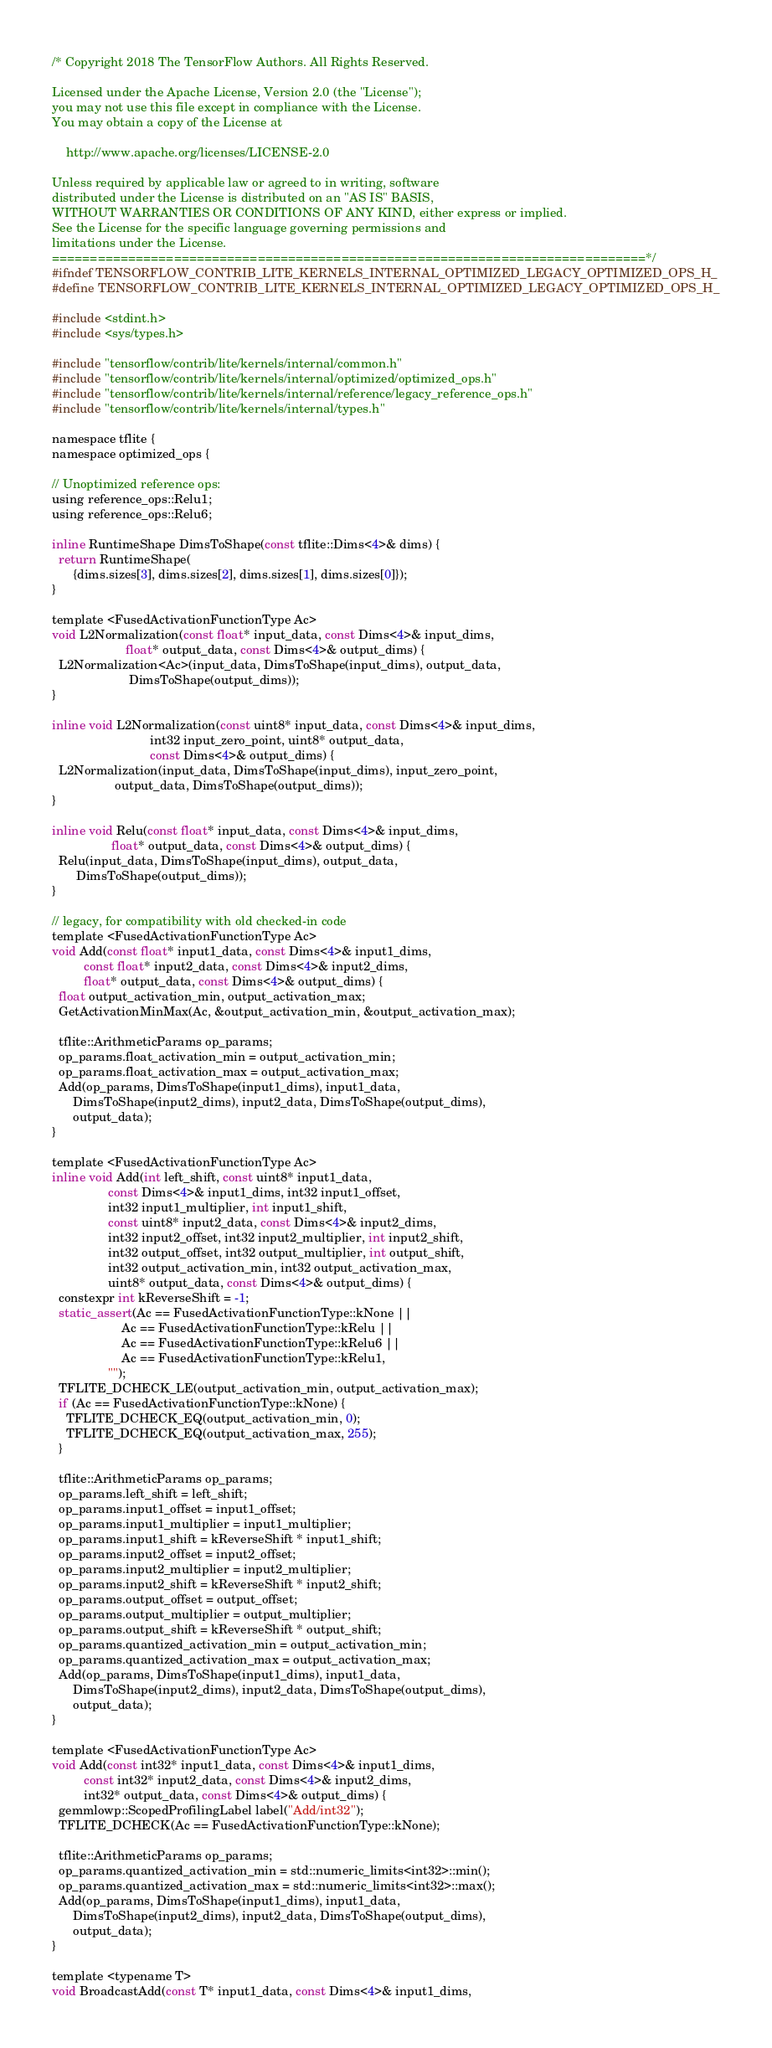<code> <loc_0><loc_0><loc_500><loc_500><_C_>/* Copyright 2018 The TensorFlow Authors. All Rights Reserved.

Licensed under the Apache License, Version 2.0 (the "License");
you may not use this file except in compliance with the License.
You may obtain a copy of the License at

    http://www.apache.org/licenses/LICENSE-2.0

Unless required by applicable law or agreed to in writing, software
distributed under the License is distributed on an "AS IS" BASIS,
WITHOUT WARRANTIES OR CONDITIONS OF ANY KIND, either express or implied.
See the License for the specific language governing permissions and
limitations under the License.
==============================================================================*/
#ifndef TENSORFLOW_CONTRIB_LITE_KERNELS_INTERNAL_OPTIMIZED_LEGACY_OPTIMIZED_OPS_H_
#define TENSORFLOW_CONTRIB_LITE_KERNELS_INTERNAL_OPTIMIZED_LEGACY_OPTIMIZED_OPS_H_

#include <stdint.h>
#include <sys/types.h>

#include "tensorflow/contrib/lite/kernels/internal/common.h"
#include "tensorflow/contrib/lite/kernels/internal/optimized/optimized_ops.h"
#include "tensorflow/contrib/lite/kernels/internal/reference/legacy_reference_ops.h"
#include "tensorflow/contrib/lite/kernels/internal/types.h"

namespace tflite {
namespace optimized_ops {

// Unoptimized reference ops:
using reference_ops::Relu1;
using reference_ops::Relu6;

inline RuntimeShape DimsToShape(const tflite::Dims<4>& dims) {
  return RuntimeShape(
      {dims.sizes[3], dims.sizes[2], dims.sizes[1], dims.sizes[0]});
}

template <FusedActivationFunctionType Ac>
void L2Normalization(const float* input_data, const Dims<4>& input_dims,
                     float* output_data, const Dims<4>& output_dims) {
  L2Normalization<Ac>(input_data, DimsToShape(input_dims), output_data,
                      DimsToShape(output_dims));
}

inline void L2Normalization(const uint8* input_data, const Dims<4>& input_dims,
                            int32 input_zero_point, uint8* output_data,
                            const Dims<4>& output_dims) {
  L2Normalization(input_data, DimsToShape(input_dims), input_zero_point,
                  output_data, DimsToShape(output_dims));
}

inline void Relu(const float* input_data, const Dims<4>& input_dims,
                 float* output_data, const Dims<4>& output_dims) {
  Relu(input_data, DimsToShape(input_dims), output_data,
       DimsToShape(output_dims));
}

// legacy, for compatibility with old checked-in code
template <FusedActivationFunctionType Ac>
void Add(const float* input1_data, const Dims<4>& input1_dims,
         const float* input2_data, const Dims<4>& input2_dims,
         float* output_data, const Dims<4>& output_dims) {
  float output_activation_min, output_activation_max;
  GetActivationMinMax(Ac, &output_activation_min, &output_activation_max);

  tflite::ArithmeticParams op_params;
  op_params.float_activation_min = output_activation_min;
  op_params.float_activation_max = output_activation_max;
  Add(op_params, DimsToShape(input1_dims), input1_data,
      DimsToShape(input2_dims), input2_data, DimsToShape(output_dims),
      output_data);
}

template <FusedActivationFunctionType Ac>
inline void Add(int left_shift, const uint8* input1_data,
                const Dims<4>& input1_dims, int32 input1_offset,
                int32 input1_multiplier, int input1_shift,
                const uint8* input2_data, const Dims<4>& input2_dims,
                int32 input2_offset, int32 input2_multiplier, int input2_shift,
                int32 output_offset, int32 output_multiplier, int output_shift,
                int32 output_activation_min, int32 output_activation_max,
                uint8* output_data, const Dims<4>& output_dims) {
  constexpr int kReverseShift = -1;
  static_assert(Ac == FusedActivationFunctionType::kNone ||
                    Ac == FusedActivationFunctionType::kRelu ||
                    Ac == FusedActivationFunctionType::kRelu6 ||
                    Ac == FusedActivationFunctionType::kRelu1,
                "");
  TFLITE_DCHECK_LE(output_activation_min, output_activation_max);
  if (Ac == FusedActivationFunctionType::kNone) {
    TFLITE_DCHECK_EQ(output_activation_min, 0);
    TFLITE_DCHECK_EQ(output_activation_max, 255);
  }

  tflite::ArithmeticParams op_params;
  op_params.left_shift = left_shift;
  op_params.input1_offset = input1_offset;
  op_params.input1_multiplier = input1_multiplier;
  op_params.input1_shift = kReverseShift * input1_shift;
  op_params.input2_offset = input2_offset;
  op_params.input2_multiplier = input2_multiplier;
  op_params.input2_shift = kReverseShift * input2_shift;
  op_params.output_offset = output_offset;
  op_params.output_multiplier = output_multiplier;
  op_params.output_shift = kReverseShift * output_shift;
  op_params.quantized_activation_min = output_activation_min;
  op_params.quantized_activation_max = output_activation_max;
  Add(op_params, DimsToShape(input1_dims), input1_data,
      DimsToShape(input2_dims), input2_data, DimsToShape(output_dims),
      output_data);
}

template <FusedActivationFunctionType Ac>
void Add(const int32* input1_data, const Dims<4>& input1_dims,
         const int32* input2_data, const Dims<4>& input2_dims,
         int32* output_data, const Dims<4>& output_dims) {
  gemmlowp::ScopedProfilingLabel label("Add/int32");
  TFLITE_DCHECK(Ac == FusedActivationFunctionType::kNone);

  tflite::ArithmeticParams op_params;
  op_params.quantized_activation_min = std::numeric_limits<int32>::min();
  op_params.quantized_activation_max = std::numeric_limits<int32>::max();
  Add(op_params, DimsToShape(input1_dims), input1_data,
      DimsToShape(input2_dims), input2_data, DimsToShape(output_dims),
      output_data);
}

template <typename T>
void BroadcastAdd(const T* input1_data, const Dims<4>& input1_dims,</code> 